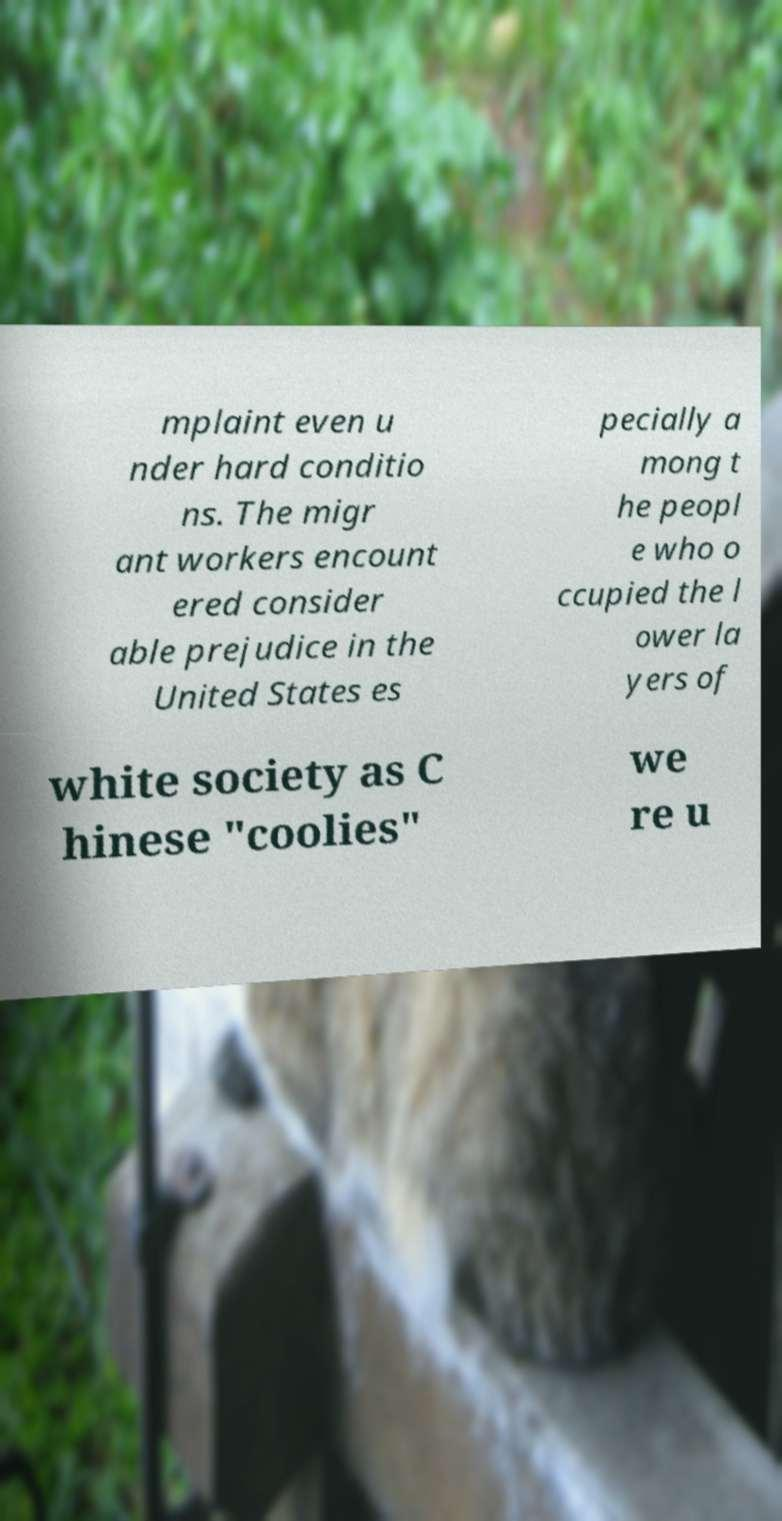Please identify and transcribe the text found in this image. mplaint even u nder hard conditio ns. The migr ant workers encount ered consider able prejudice in the United States es pecially a mong t he peopl e who o ccupied the l ower la yers of white society as C hinese "coolies" we re u 